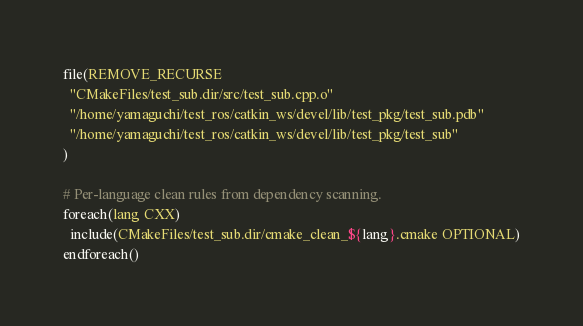Convert code to text. <code><loc_0><loc_0><loc_500><loc_500><_CMake_>file(REMOVE_RECURSE
  "CMakeFiles/test_sub.dir/src/test_sub.cpp.o"
  "/home/yamaguchi/test_ros/catkin_ws/devel/lib/test_pkg/test_sub.pdb"
  "/home/yamaguchi/test_ros/catkin_ws/devel/lib/test_pkg/test_sub"
)

# Per-language clean rules from dependency scanning.
foreach(lang CXX)
  include(CMakeFiles/test_sub.dir/cmake_clean_${lang}.cmake OPTIONAL)
endforeach()
</code> 